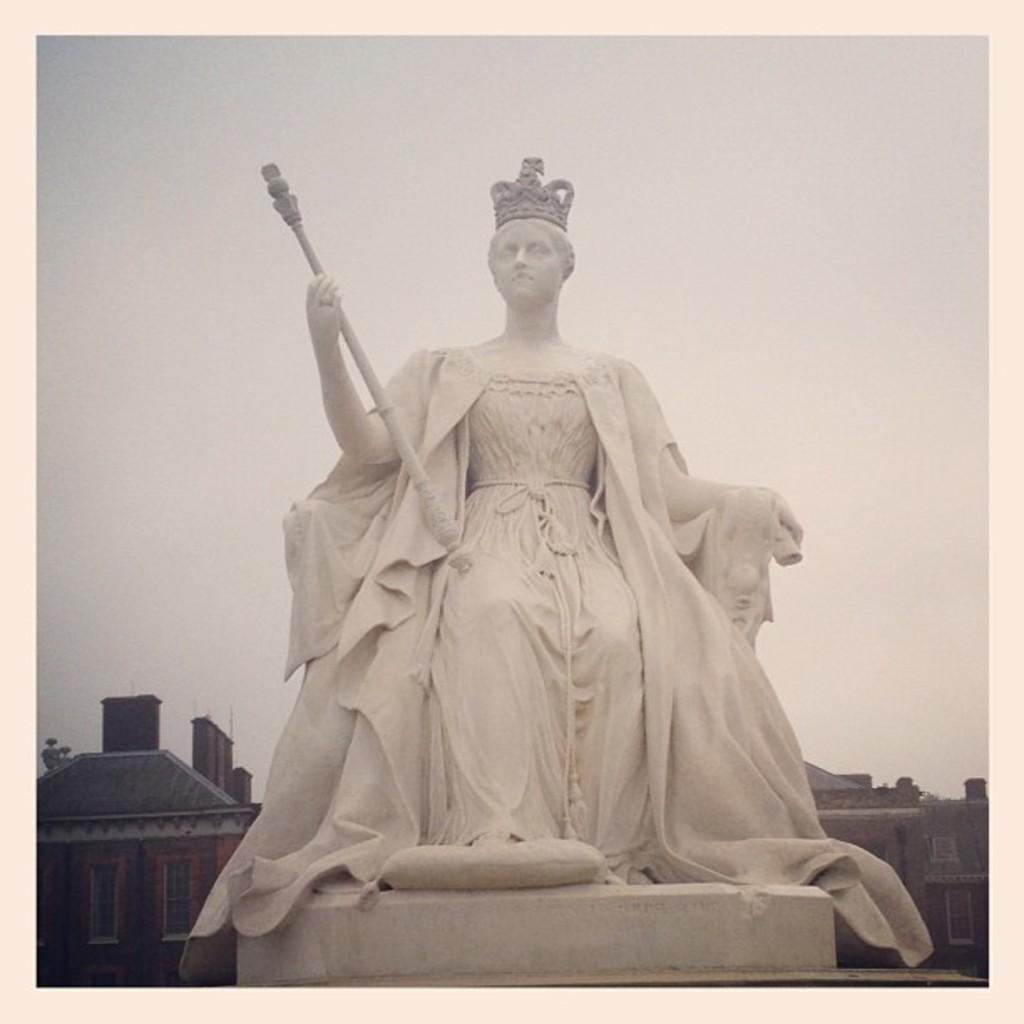What is the main subject of the image? There is a statue of a woman in the image. What is the woman holding in the image? The woman is holding an object in the image. How is the object being displayed? The object is placed on a pedestal. What can be seen in the background of the image? Buildings, the sky, and windows are visible in the background of the image. How many tickets are being sold to the cattle in the image? There are no tickets or cattle present in the image; it features a statue of a woman holding an object on a pedestal. 